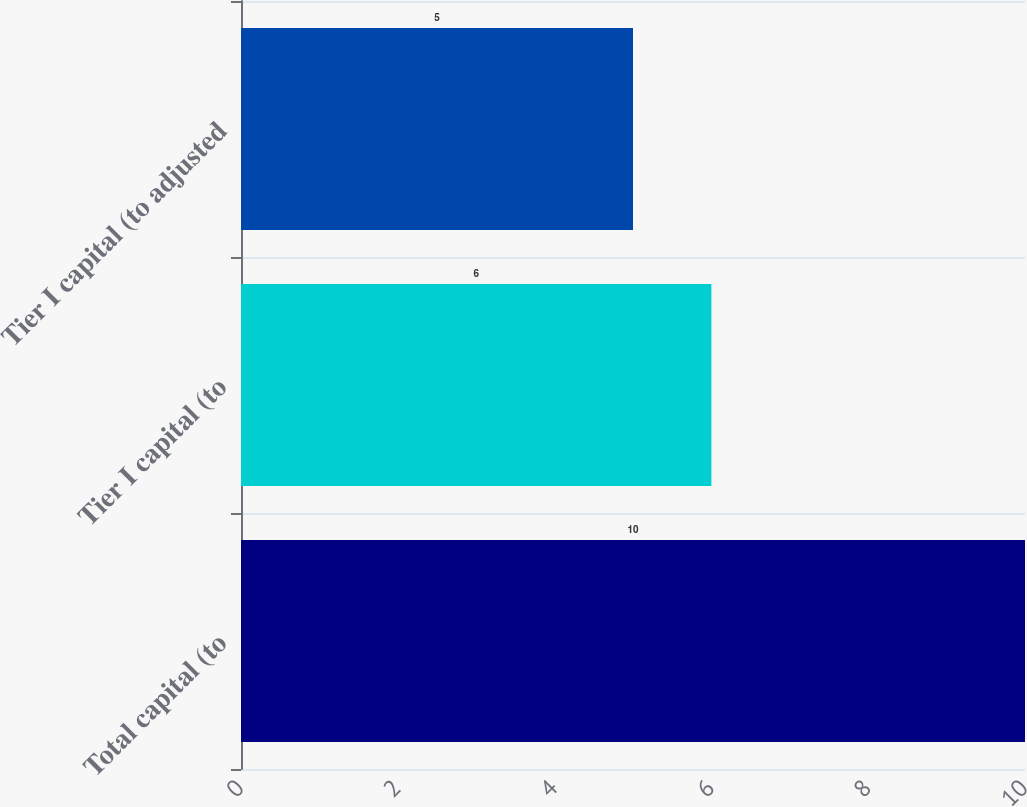Convert chart to OTSL. <chart><loc_0><loc_0><loc_500><loc_500><bar_chart><fcel>Total capital (to<fcel>Tier I capital (to<fcel>Tier I capital (to adjusted<nl><fcel>10<fcel>6<fcel>5<nl></chart> 